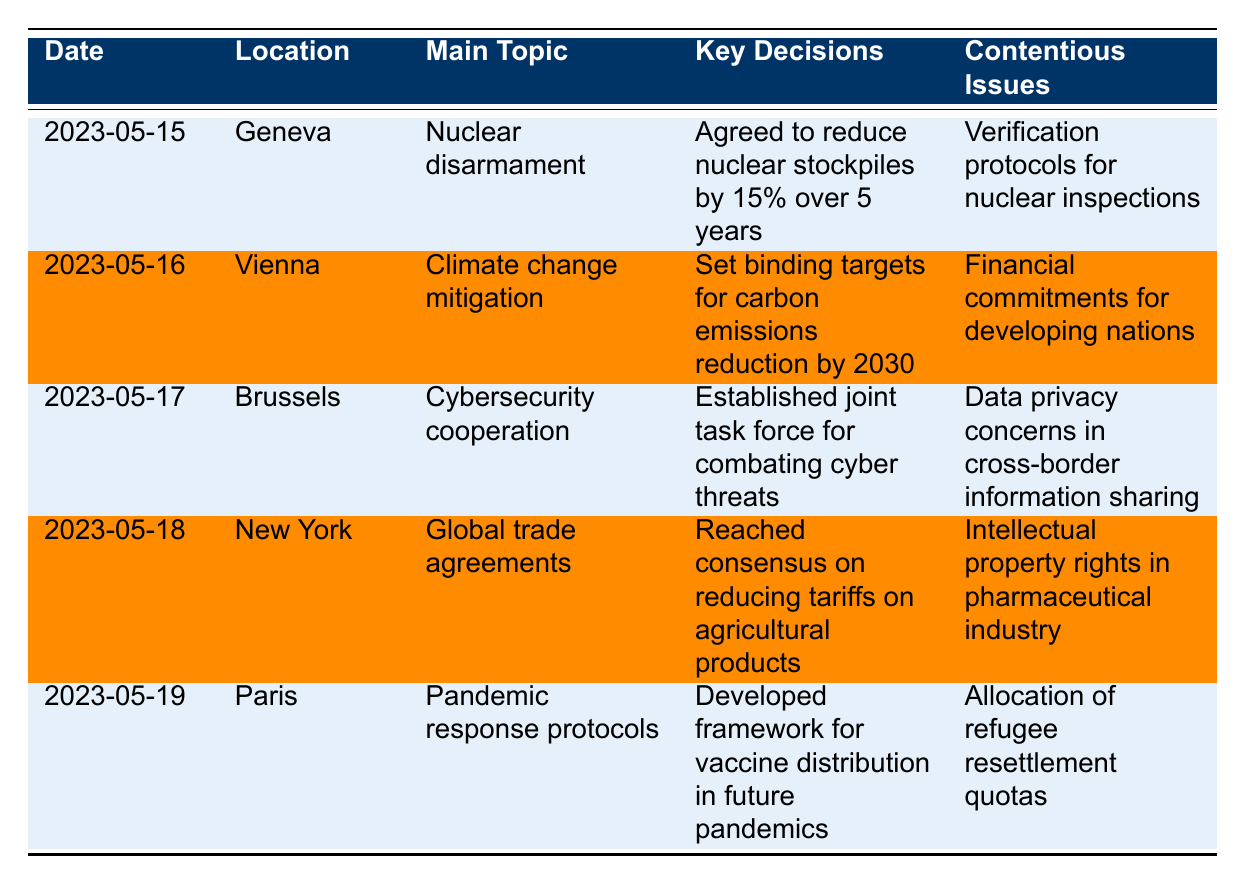What was the main topic of the meeting held on May 17, 2023? The table lists the main topics of each meeting by date. For May 17, 2023, the main topic is cybersecurity cooperation.
Answer: Cybersecurity cooperation How many countries participated in the meeting on May 18, 2023? The table indicates the participating countries for each meeting. On May 18, 2023, there were five participating countries listed.
Answer: 5 Which location hosted discussions on nuclear disarmament? By checking the table, we see that the meeting on May 15, 2023, which focused on nuclear disarmament, was held in Geneva.
Answer: Geneva Did any of the meetings involve discussions about climate change? The table shows that climate change mitigation was a main topic discussed on May 16, 2023. Therefore, yes, there were discussions about climate change.
Answer: Yes What are the key decisions from the meetings in chronological order? The table lists key decisions for each meeting by date. Following the order from May 15 to May 19, the decisions are: reduce nuclear stockpiles, set carbon emissions reduction targets, establish cybersecurity task force, reduce tariffs on agricultural products, and develop vaccine distribution framework.
Answer: 1. Reduce nuclear stockpiles 2. Set carbon emissions reduction targets 3. Establish cybersecurity task force 4. Reduce tariffs on agricultural products 5. Develop vaccine distribution framework Which meeting had the most contentious issues, and what were they? Each meeting has a specified contentious issue listed. By reviewing the table, there is one contentious issue per meeting, so all meetings had equal numbers. The contentious issues are: nuclear inspections, financial commitments, data privacy, intellectual property, and refugee resettlement quotas.
Answer: Equal number for each; issues: 1. Nuclear inspections 2. Financial commitments 3. Data privacy 4. Intellectual property 5. Refugee resettlement quotas What unexpected development occurred during the meeting in Brussels? The table provides unexpected developments for each meeting, and for May 17, 2023, in Brussels, it mentions the establishment of a joint task force for combating cyber threats but does not list an unexpected development specifically for that date.
Answer: None listed If the follow-up meetings are scheduled every three months, when is the next follow-up after May 19, 2023? The follow-up meetings are mentioned in the next steps and the last meeting was on May 19, 2023. Adding three months to this date gives us August 19, 2023.
Answer: August 19, 2023 Which meeting focused on pandemic response and what was the key decision made? The table indicates that the meeting on May 19, 2023, focused on pandemic response protocols, with a key decision to develop a framework for vaccine distribution in future pandemics.
Answer: May 19, 2023; Develop a framework for vaccine distribution 